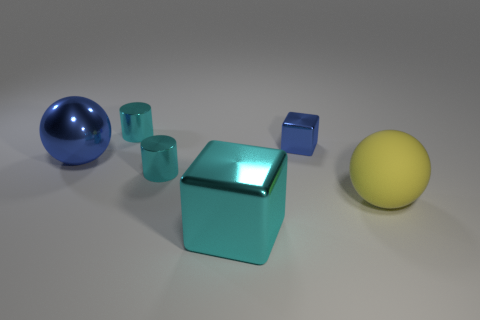How many objects in total are there in this image? There are a total of 5 objects depicted in the image: one large yellow rubber ball, one blue rubber ball, one cyan block, and two small green rubber cubes. Which object seems to be in the foreground? The large yellow rubber ball appears to be the object positioned in the foreground, as it seems closer to the viewpoint compared to the other objects. 